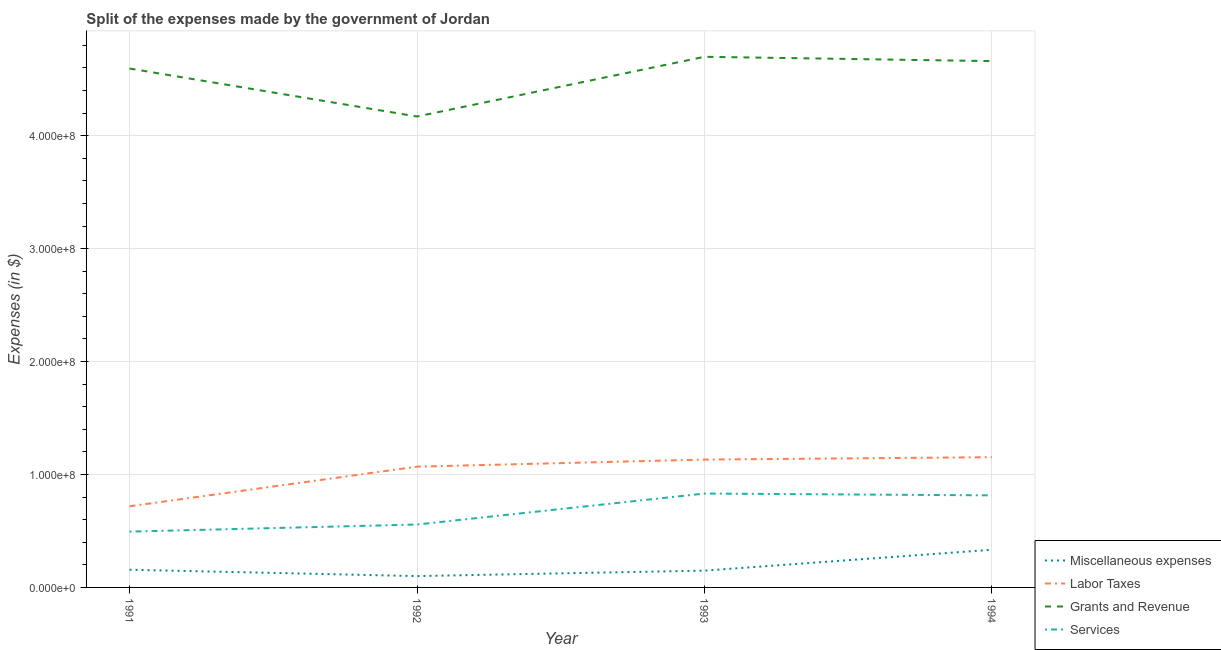How many different coloured lines are there?
Provide a short and direct response. 4. Is the number of lines equal to the number of legend labels?
Offer a very short reply. Yes. What is the amount spent on labor taxes in 1994?
Your response must be concise. 1.15e+08. Across all years, what is the maximum amount spent on services?
Your answer should be compact. 8.31e+07. Across all years, what is the minimum amount spent on miscellaneous expenses?
Ensure brevity in your answer.  1.00e+07. In which year was the amount spent on services minimum?
Provide a short and direct response. 1991. What is the total amount spent on services in the graph?
Your answer should be compact. 2.70e+08. What is the difference between the amount spent on services in 1992 and that in 1993?
Make the answer very short. -2.74e+07. What is the difference between the amount spent on services in 1993 and the amount spent on labor taxes in 1991?
Offer a very short reply. 1.13e+07. What is the average amount spent on labor taxes per year?
Your answer should be very brief. 1.02e+08. In the year 1994, what is the difference between the amount spent on labor taxes and amount spent on grants and revenue?
Make the answer very short. -3.51e+08. In how many years, is the amount spent on labor taxes greater than 440000000 $?
Your answer should be very brief. 0. What is the ratio of the amount spent on services in 1991 to that in 1992?
Provide a short and direct response. 0.89. What is the difference between the highest and the second highest amount spent on miscellaneous expenses?
Your answer should be compact. 1.77e+07. What is the difference between the highest and the lowest amount spent on labor taxes?
Make the answer very short. 4.35e+07. Is the sum of the amount spent on miscellaneous expenses in 1991 and 1992 greater than the maximum amount spent on grants and revenue across all years?
Your response must be concise. No. Is the amount spent on labor taxes strictly greater than the amount spent on services over the years?
Your answer should be compact. Yes. Is the amount spent on grants and revenue strictly less than the amount spent on services over the years?
Keep it short and to the point. No. How many lines are there?
Ensure brevity in your answer.  4. How many years are there in the graph?
Give a very brief answer. 4. Does the graph contain any zero values?
Your answer should be compact. No. Does the graph contain grids?
Keep it short and to the point. Yes. How are the legend labels stacked?
Your answer should be very brief. Vertical. What is the title of the graph?
Give a very brief answer. Split of the expenses made by the government of Jordan. What is the label or title of the Y-axis?
Make the answer very short. Expenses (in $). What is the Expenses (in $) in Miscellaneous expenses in 1991?
Your answer should be compact. 1.57e+07. What is the Expenses (in $) in Labor Taxes in 1991?
Keep it short and to the point. 7.18e+07. What is the Expenses (in $) of Grants and Revenue in 1991?
Offer a very short reply. 4.59e+08. What is the Expenses (in $) of Services in 1991?
Give a very brief answer. 4.94e+07. What is the Expenses (in $) in Miscellaneous expenses in 1992?
Make the answer very short. 1.00e+07. What is the Expenses (in $) in Labor Taxes in 1992?
Your response must be concise. 1.07e+08. What is the Expenses (in $) in Grants and Revenue in 1992?
Your answer should be very brief. 4.17e+08. What is the Expenses (in $) of Services in 1992?
Your answer should be very brief. 5.57e+07. What is the Expenses (in $) of Miscellaneous expenses in 1993?
Your response must be concise. 1.49e+07. What is the Expenses (in $) in Labor Taxes in 1993?
Your answer should be very brief. 1.13e+08. What is the Expenses (in $) in Grants and Revenue in 1993?
Keep it short and to the point. 4.70e+08. What is the Expenses (in $) in Services in 1993?
Keep it short and to the point. 8.31e+07. What is the Expenses (in $) in Miscellaneous expenses in 1994?
Your answer should be compact. 3.34e+07. What is the Expenses (in $) in Labor Taxes in 1994?
Ensure brevity in your answer.  1.15e+08. What is the Expenses (in $) of Grants and Revenue in 1994?
Offer a terse response. 4.66e+08. What is the Expenses (in $) in Services in 1994?
Provide a short and direct response. 8.15e+07. Across all years, what is the maximum Expenses (in $) in Miscellaneous expenses?
Offer a terse response. 3.34e+07. Across all years, what is the maximum Expenses (in $) in Labor Taxes?
Keep it short and to the point. 1.15e+08. Across all years, what is the maximum Expenses (in $) of Grants and Revenue?
Offer a very short reply. 4.70e+08. Across all years, what is the maximum Expenses (in $) of Services?
Your answer should be very brief. 8.31e+07. Across all years, what is the minimum Expenses (in $) in Miscellaneous expenses?
Provide a short and direct response. 1.00e+07. Across all years, what is the minimum Expenses (in $) of Labor Taxes?
Your answer should be compact. 7.18e+07. Across all years, what is the minimum Expenses (in $) in Grants and Revenue?
Offer a terse response. 4.17e+08. Across all years, what is the minimum Expenses (in $) in Services?
Your answer should be very brief. 4.94e+07. What is the total Expenses (in $) of Miscellaneous expenses in the graph?
Your response must be concise. 7.39e+07. What is the total Expenses (in $) in Labor Taxes in the graph?
Provide a succinct answer. 4.07e+08. What is the total Expenses (in $) in Grants and Revenue in the graph?
Your response must be concise. 1.81e+09. What is the total Expenses (in $) of Services in the graph?
Keep it short and to the point. 2.70e+08. What is the difference between the Expenses (in $) of Miscellaneous expenses in 1991 and that in 1992?
Give a very brief answer. 5.62e+06. What is the difference between the Expenses (in $) of Labor Taxes in 1991 and that in 1992?
Offer a terse response. -3.51e+07. What is the difference between the Expenses (in $) of Grants and Revenue in 1991 and that in 1992?
Ensure brevity in your answer.  4.25e+07. What is the difference between the Expenses (in $) in Services in 1991 and that in 1992?
Your answer should be very brief. -6.29e+06. What is the difference between the Expenses (in $) in Miscellaneous expenses in 1991 and that in 1993?
Provide a succinct answer. 7.90e+05. What is the difference between the Expenses (in $) in Labor Taxes in 1991 and that in 1993?
Your response must be concise. -4.14e+07. What is the difference between the Expenses (in $) of Grants and Revenue in 1991 and that in 1993?
Provide a short and direct response. -1.04e+07. What is the difference between the Expenses (in $) of Services in 1991 and that in 1993?
Offer a very short reply. -3.37e+07. What is the difference between the Expenses (in $) of Miscellaneous expenses in 1991 and that in 1994?
Make the answer very short. -1.77e+07. What is the difference between the Expenses (in $) of Labor Taxes in 1991 and that in 1994?
Your answer should be very brief. -4.35e+07. What is the difference between the Expenses (in $) of Grants and Revenue in 1991 and that in 1994?
Offer a terse response. -6.55e+06. What is the difference between the Expenses (in $) of Services in 1991 and that in 1994?
Make the answer very short. -3.21e+07. What is the difference between the Expenses (in $) of Miscellaneous expenses in 1992 and that in 1993?
Ensure brevity in your answer.  -4.83e+06. What is the difference between the Expenses (in $) in Labor Taxes in 1992 and that in 1993?
Your answer should be compact. -6.27e+06. What is the difference between the Expenses (in $) in Grants and Revenue in 1992 and that in 1993?
Offer a very short reply. -5.29e+07. What is the difference between the Expenses (in $) of Services in 1992 and that in 1993?
Provide a succinct answer. -2.74e+07. What is the difference between the Expenses (in $) in Miscellaneous expenses in 1992 and that in 1994?
Offer a very short reply. -2.33e+07. What is the difference between the Expenses (in $) of Labor Taxes in 1992 and that in 1994?
Offer a terse response. -8.38e+06. What is the difference between the Expenses (in $) in Grants and Revenue in 1992 and that in 1994?
Your response must be concise. -4.90e+07. What is the difference between the Expenses (in $) of Services in 1992 and that in 1994?
Make the answer very short. -2.58e+07. What is the difference between the Expenses (in $) in Miscellaneous expenses in 1993 and that in 1994?
Ensure brevity in your answer.  -1.85e+07. What is the difference between the Expenses (in $) in Labor Taxes in 1993 and that in 1994?
Your response must be concise. -2.11e+06. What is the difference between the Expenses (in $) of Grants and Revenue in 1993 and that in 1994?
Your answer should be very brief. 3.83e+06. What is the difference between the Expenses (in $) in Services in 1993 and that in 1994?
Make the answer very short. 1.60e+06. What is the difference between the Expenses (in $) in Miscellaneous expenses in 1991 and the Expenses (in $) in Labor Taxes in 1992?
Give a very brief answer. -9.13e+07. What is the difference between the Expenses (in $) of Miscellaneous expenses in 1991 and the Expenses (in $) of Grants and Revenue in 1992?
Make the answer very short. -4.01e+08. What is the difference between the Expenses (in $) in Miscellaneous expenses in 1991 and the Expenses (in $) in Services in 1992?
Offer a terse response. -4.00e+07. What is the difference between the Expenses (in $) in Labor Taxes in 1991 and the Expenses (in $) in Grants and Revenue in 1992?
Offer a terse response. -3.45e+08. What is the difference between the Expenses (in $) in Labor Taxes in 1991 and the Expenses (in $) in Services in 1992?
Your answer should be very brief. 1.62e+07. What is the difference between the Expenses (in $) in Grants and Revenue in 1991 and the Expenses (in $) in Services in 1992?
Offer a very short reply. 4.04e+08. What is the difference between the Expenses (in $) in Miscellaneous expenses in 1991 and the Expenses (in $) in Labor Taxes in 1993?
Provide a short and direct response. -9.75e+07. What is the difference between the Expenses (in $) of Miscellaneous expenses in 1991 and the Expenses (in $) of Grants and Revenue in 1993?
Provide a succinct answer. -4.54e+08. What is the difference between the Expenses (in $) of Miscellaneous expenses in 1991 and the Expenses (in $) of Services in 1993?
Give a very brief answer. -6.75e+07. What is the difference between the Expenses (in $) in Labor Taxes in 1991 and the Expenses (in $) in Grants and Revenue in 1993?
Make the answer very short. -3.98e+08. What is the difference between the Expenses (in $) of Labor Taxes in 1991 and the Expenses (in $) of Services in 1993?
Offer a terse response. -1.13e+07. What is the difference between the Expenses (in $) of Grants and Revenue in 1991 and the Expenses (in $) of Services in 1993?
Ensure brevity in your answer.  3.76e+08. What is the difference between the Expenses (in $) in Miscellaneous expenses in 1991 and the Expenses (in $) in Labor Taxes in 1994?
Ensure brevity in your answer.  -9.96e+07. What is the difference between the Expenses (in $) in Miscellaneous expenses in 1991 and the Expenses (in $) in Grants and Revenue in 1994?
Your answer should be very brief. -4.50e+08. What is the difference between the Expenses (in $) of Miscellaneous expenses in 1991 and the Expenses (in $) of Services in 1994?
Provide a succinct answer. -6.59e+07. What is the difference between the Expenses (in $) of Labor Taxes in 1991 and the Expenses (in $) of Grants and Revenue in 1994?
Ensure brevity in your answer.  -3.94e+08. What is the difference between the Expenses (in $) in Labor Taxes in 1991 and the Expenses (in $) in Services in 1994?
Ensure brevity in your answer.  -9.67e+06. What is the difference between the Expenses (in $) of Grants and Revenue in 1991 and the Expenses (in $) of Services in 1994?
Ensure brevity in your answer.  3.78e+08. What is the difference between the Expenses (in $) in Miscellaneous expenses in 1992 and the Expenses (in $) in Labor Taxes in 1993?
Provide a short and direct response. -1.03e+08. What is the difference between the Expenses (in $) in Miscellaneous expenses in 1992 and the Expenses (in $) in Grants and Revenue in 1993?
Make the answer very short. -4.60e+08. What is the difference between the Expenses (in $) in Miscellaneous expenses in 1992 and the Expenses (in $) in Services in 1993?
Your answer should be very brief. -7.31e+07. What is the difference between the Expenses (in $) of Labor Taxes in 1992 and the Expenses (in $) of Grants and Revenue in 1993?
Your answer should be very brief. -3.63e+08. What is the difference between the Expenses (in $) of Labor Taxes in 1992 and the Expenses (in $) of Services in 1993?
Give a very brief answer. 2.38e+07. What is the difference between the Expenses (in $) in Grants and Revenue in 1992 and the Expenses (in $) in Services in 1993?
Ensure brevity in your answer.  3.34e+08. What is the difference between the Expenses (in $) in Miscellaneous expenses in 1992 and the Expenses (in $) in Labor Taxes in 1994?
Make the answer very short. -1.05e+08. What is the difference between the Expenses (in $) in Miscellaneous expenses in 1992 and the Expenses (in $) in Grants and Revenue in 1994?
Provide a succinct answer. -4.56e+08. What is the difference between the Expenses (in $) in Miscellaneous expenses in 1992 and the Expenses (in $) in Services in 1994?
Provide a short and direct response. -7.15e+07. What is the difference between the Expenses (in $) of Labor Taxes in 1992 and the Expenses (in $) of Grants and Revenue in 1994?
Offer a very short reply. -3.59e+08. What is the difference between the Expenses (in $) of Labor Taxes in 1992 and the Expenses (in $) of Services in 1994?
Give a very brief answer. 2.54e+07. What is the difference between the Expenses (in $) of Grants and Revenue in 1992 and the Expenses (in $) of Services in 1994?
Your answer should be compact. 3.35e+08. What is the difference between the Expenses (in $) of Miscellaneous expenses in 1993 and the Expenses (in $) of Labor Taxes in 1994?
Ensure brevity in your answer.  -1.00e+08. What is the difference between the Expenses (in $) in Miscellaneous expenses in 1993 and the Expenses (in $) in Grants and Revenue in 1994?
Provide a short and direct response. -4.51e+08. What is the difference between the Expenses (in $) of Miscellaneous expenses in 1993 and the Expenses (in $) of Services in 1994?
Your answer should be very brief. -6.66e+07. What is the difference between the Expenses (in $) of Labor Taxes in 1993 and the Expenses (in $) of Grants and Revenue in 1994?
Your answer should be compact. -3.53e+08. What is the difference between the Expenses (in $) of Labor Taxes in 1993 and the Expenses (in $) of Services in 1994?
Make the answer very short. 3.17e+07. What is the difference between the Expenses (in $) in Grants and Revenue in 1993 and the Expenses (in $) in Services in 1994?
Your response must be concise. 3.88e+08. What is the average Expenses (in $) in Miscellaneous expenses per year?
Keep it short and to the point. 1.85e+07. What is the average Expenses (in $) in Labor Taxes per year?
Provide a short and direct response. 1.02e+08. What is the average Expenses (in $) of Grants and Revenue per year?
Offer a terse response. 4.53e+08. What is the average Expenses (in $) in Services per year?
Offer a very short reply. 6.74e+07. In the year 1991, what is the difference between the Expenses (in $) of Miscellaneous expenses and Expenses (in $) of Labor Taxes?
Your answer should be compact. -5.62e+07. In the year 1991, what is the difference between the Expenses (in $) in Miscellaneous expenses and Expenses (in $) in Grants and Revenue?
Offer a very short reply. -4.44e+08. In the year 1991, what is the difference between the Expenses (in $) of Miscellaneous expenses and Expenses (in $) of Services?
Provide a succinct answer. -3.38e+07. In the year 1991, what is the difference between the Expenses (in $) of Labor Taxes and Expenses (in $) of Grants and Revenue?
Your answer should be compact. -3.88e+08. In the year 1991, what is the difference between the Expenses (in $) of Labor Taxes and Expenses (in $) of Services?
Make the answer very short. 2.24e+07. In the year 1991, what is the difference between the Expenses (in $) of Grants and Revenue and Expenses (in $) of Services?
Your answer should be very brief. 4.10e+08. In the year 1992, what is the difference between the Expenses (in $) in Miscellaneous expenses and Expenses (in $) in Labor Taxes?
Your response must be concise. -9.69e+07. In the year 1992, what is the difference between the Expenses (in $) of Miscellaneous expenses and Expenses (in $) of Grants and Revenue?
Your answer should be very brief. -4.07e+08. In the year 1992, what is the difference between the Expenses (in $) in Miscellaneous expenses and Expenses (in $) in Services?
Your answer should be very brief. -4.57e+07. In the year 1992, what is the difference between the Expenses (in $) in Labor Taxes and Expenses (in $) in Grants and Revenue?
Offer a terse response. -3.10e+08. In the year 1992, what is the difference between the Expenses (in $) of Labor Taxes and Expenses (in $) of Services?
Give a very brief answer. 5.12e+07. In the year 1992, what is the difference between the Expenses (in $) in Grants and Revenue and Expenses (in $) in Services?
Give a very brief answer. 3.61e+08. In the year 1993, what is the difference between the Expenses (in $) of Miscellaneous expenses and Expenses (in $) of Labor Taxes?
Offer a terse response. -9.83e+07. In the year 1993, what is the difference between the Expenses (in $) in Miscellaneous expenses and Expenses (in $) in Grants and Revenue?
Provide a succinct answer. -4.55e+08. In the year 1993, what is the difference between the Expenses (in $) of Miscellaneous expenses and Expenses (in $) of Services?
Offer a terse response. -6.82e+07. In the year 1993, what is the difference between the Expenses (in $) of Labor Taxes and Expenses (in $) of Grants and Revenue?
Give a very brief answer. -3.57e+08. In the year 1993, what is the difference between the Expenses (in $) in Labor Taxes and Expenses (in $) in Services?
Provide a succinct answer. 3.01e+07. In the year 1993, what is the difference between the Expenses (in $) of Grants and Revenue and Expenses (in $) of Services?
Your response must be concise. 3.87e+08. In the year 1994, what is the difference between the Expenses (in $) in Miscellaneous expenses and Expenses (in $) in Labor Taxes?
Offer a terse response. -8.19e+07. In the year 1994, what is the difference between the Expenses (in $) of Miscellaneous expenses and Expenses (in $) of Grants and Revenue?
Ensure brevity in your answer.  -4.33e+08. In the year 1994, what is the difference between the Expenses (in $) in Miscellaneous expenses and Expenses (in $) in Services?
Provide a succinct answer. -4.82e+07. In the year 1994, what is the difference between the Expenses (in $) of Labor Taxes and Expenses (in $) of Grants and Revenue?
Offer a terse response. -3.51e+08. In the year 1994, what is the difference between the Expenses (in $) in Labor Taxes and Expenses (in $) in Services?
Offer a terse response. 3.38e+07. In the year 1994, what is the difference between the Expenses (in $) in Grants and Revenue and Expenses (in $) in Services?
Your answer should be compact. 3.84e+08. What is the ratio of the Expenses (in $) in Miscellaneous expenses in 1991 to that in 1992?
Offer a very short reply. 1.56. What is the ratio of the Expenses (in $) in Labor Taxes in 1991 to that in 1992?
Offer a very short reply. 0.67. What is the ratio of the Expenses (in $) in Grants and Revenue in 1991 to that in 1992?
Offer a terse response. 1.1. What is the ratio of the Expenses (in $) in Services in 1991 to that in 1992?
Your response must be concise. 0.89. What is the ratio of the Expenses (in $) in Miscellaneous expenses in 1991 to that in 1993?
Offer a terse response. 1.05. What is the ratio of the Expenses (in $) of Labor Taxes in 1991 to that in 1993?
Provide a short and direct response. 0.63. What is the ratio of the Expenses (in $) in Grants and Revenue in 1991 to that in 1993?
Give a very brief answer. 0.98. What is the ratio of the Expenses (in $) of Services in 1991 to that in 1993?
Keep it short and to the point. 0.59. What is the ratio of the Expenses (in $) in Miscellaneous expenses in 1991 to that in 1994?
Provide a short and direct response. 0.47. What is the ratio of the Expenses (in $) of Labor Taxes in 1991 to that in 1994?
Offer a very short reply. 0.62. What is the ratio of the Expenses (in $) in Grants and Revenue in 1991 to that in 1994?
Provide a succinct answer. 0.99. What is the ratio of the Expenses (in $) in Services in 1991 to that in 1994?
Keep it short and to the point. 0.61. What is the ratio of the Expenses (in $) in Miscellaneous expenses in 1992 to that in 1993?
Ensure brevity in your answer.  0.68. What is the ratio of the Expenses (in $) of Labor Taxes in 1992 to that in 1993?
Ensure brevity in your answer.  0.94. What is the ratio of the Expenses (in $) of Grants and Revenue in 1992 to that in 1993?
Make the answer very short. 0.89. What is the ratio of the Expenses (in $) of Services in 1992 to that in 1993?
Your response must be concise. 0.67. What is the ratio of the Expenses (in $) in Miscellaneous expenses in 1992 to that in 1994?
Keep it short and to the point. 0.3. What is the ratio of the Expenses (in $) of Labor Taxes in 1992 to that in 1994?
Offer a terse response. 0.93. What is the ratio of the Expenses (in $) in Grants and Revenue in 1992 to that in 1994?
Provide a succinct answer. 0.89. What is the ratio of the Expenses (in $) in Services in 1992 to that in 1994?
Ensure brevity in your answer.  0.68. What is the ratio of the Expenses (in $) of Miscellaneous expenses in 1993 to that in 1994?
Ensure brevity in your answer.  0.45. What is the ratio of the Expenses (in $) of Labor Taxes in 1993 to that in 1994?
Your response must be concise. 0.98. What is the ratio of the Expenses (in $) in Grants and Revenue in 1993 to that in 1994?
Give a very brief answer. 1.01. What is the ratio of the Expenses (in $) of Services in 1993 to that in 1994?
Offer a terse response. 1.02. What is the difference between the highest and the second highest Expenses (in $) of Miscellaneous expenses?
Your answer should be compact. 1.77e+07. What is the difference between the highest and the second highest Expenses (in $) in Labor Taxes?
Your answer should be very brief. 2.11e+06. What is the difference between the highest and the second highest Expenses (in $) of Grants and Revenue?
Offer a terse response. 3.83e+06. What is the difference between the highest and the second highest Expenses (in $) in Services?
Your answer should be very brief. 1.60e+06. What is the difference between the highest and the lowest Expenses (in $) in Miscellaneous expenses?
Your answer should be very brief. 2.33e+07. What is the difference between the highest and the lowest Expenses (in $) in Labor Taxes?
Your answer should be very brief. 4.35e+07. What is the difference between the highest and the lowest Expenses (in $) in Grants and Revenue?
Make the answer very short. 5.29e+07. What is the difference between the highest and the lowest Expenses (in $) of Services?
Provide a short and direct response. 3.37e+07. 